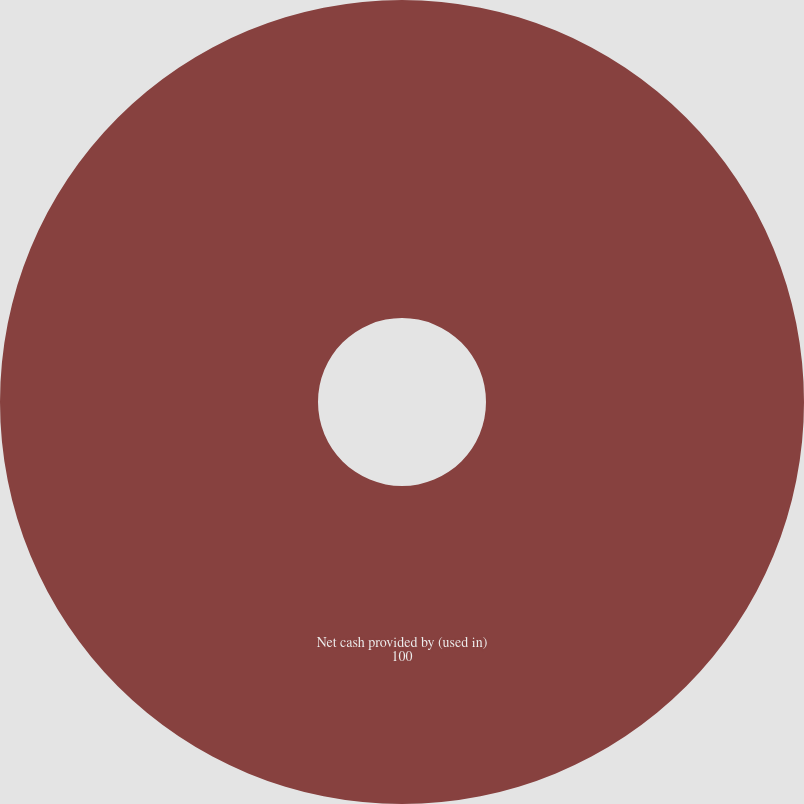Convert chart to OTSL. <chart><loc_0><loc_0><loc_500><loc_500><pie_chart><fcel>Net cash provided by (used in)<nl><fcel>100.0%<nl></chart> 